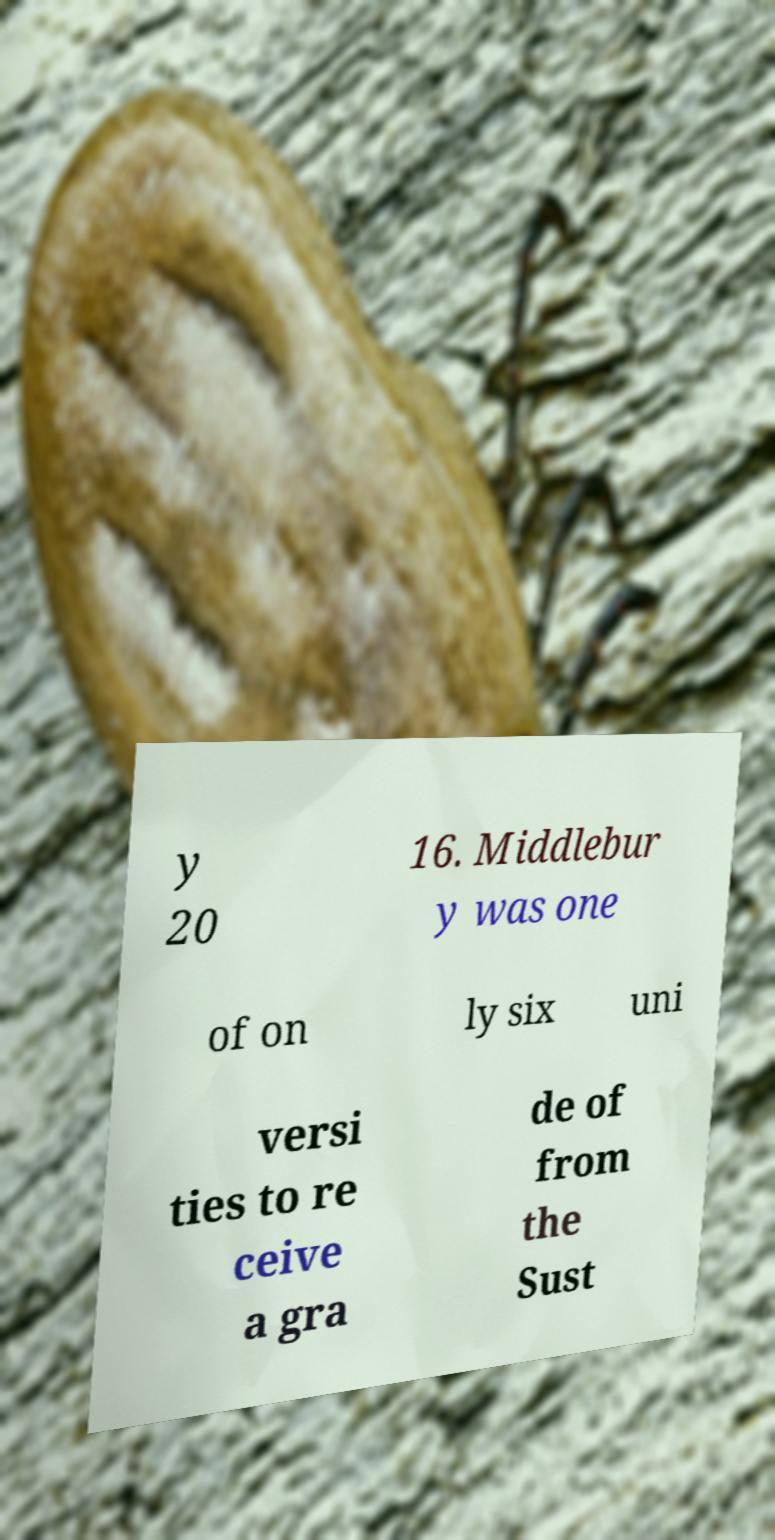Could you assist in decoding the text presented in this image and type it out clearly? y 20 16. Middlebur y was one of on ly six uni versi ties to re ceive a gra de of from the Sust 